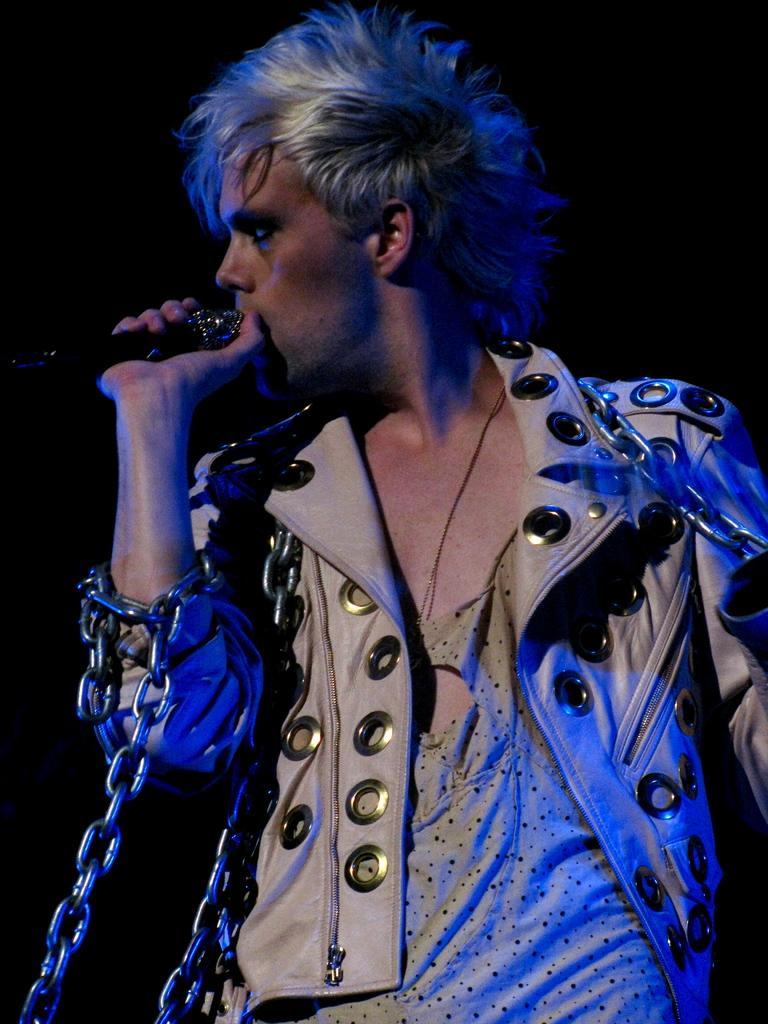Can you describe this image briefly? In this picture there is a man wearing white color jacket with chains in the hand, singing on the microphone. Behind there is a black color background. 